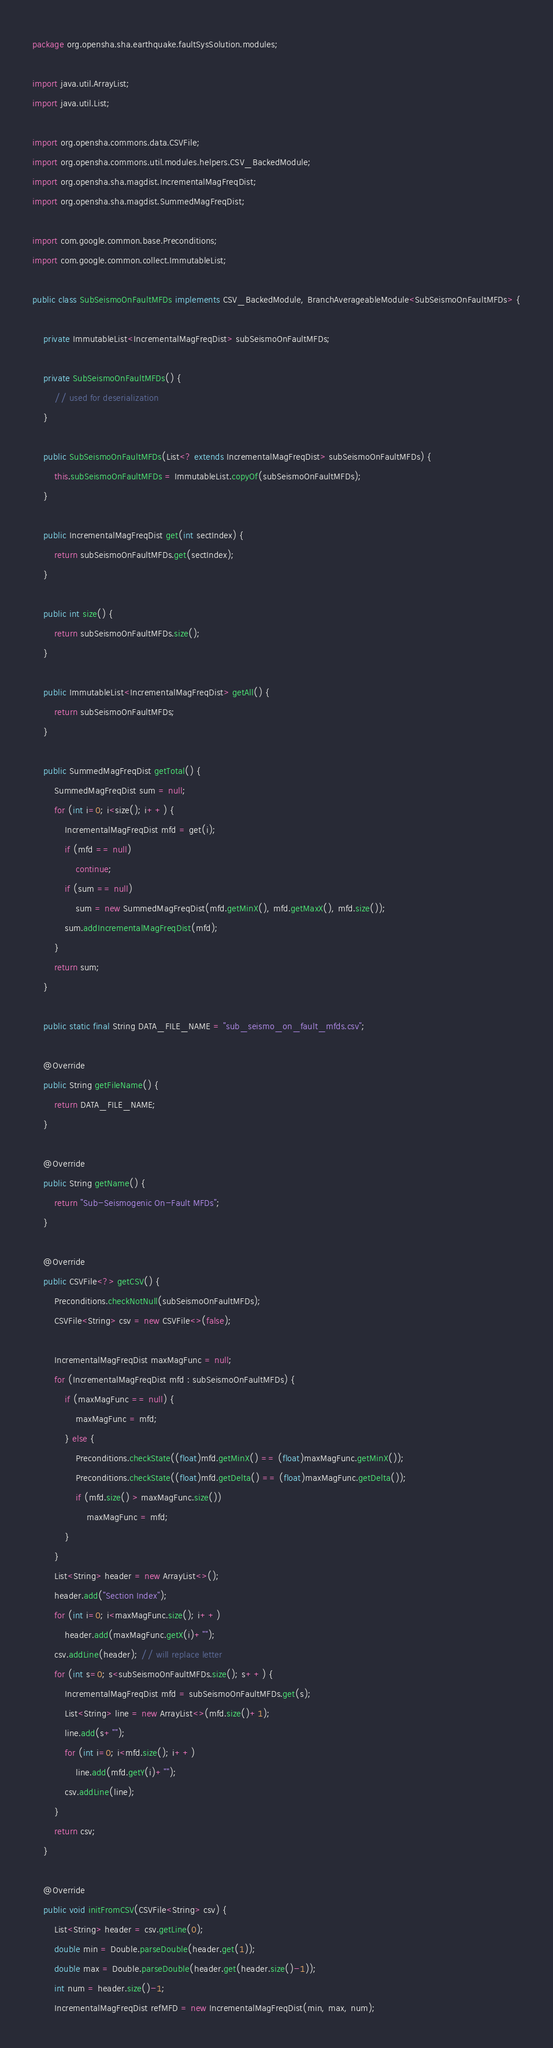Convert code to text. <code><loc_0><loc_0><loc_500><loc_500><_Java_>package org.opensha.sha.earthquake.faultSysSolution.modules;

import java.util.ArrayList;
import java.util.List;

import org.opensha.commons.data.CSVFile;
import org.opensha.commons.util.modules.helpers.CSV_BackedModule;
import org.opensha.sha.magdist.IncrementalMagFreqDist;
import org.opensha.sha.magdist.SummedMagFreqDist;

import com.google.common.base.Preconditions;
import com.google.common.collect.ImmutableList;

public class SubSeismoOnFaultMFDs implements CSV_BackedModule, BranchAverageableModule<SubSeismoOnFaultMFDs> {
	
	private ImmutableList<IncrementalMagFreqDist> subSeismoOnFaultMFDs;
	
	private SubSeismoOnFaultMFDs() {
		// used for deserialization
	}
	
	public SubSeismoOnFaultMFDs(List<? extends IncrementalMagFreqDist> subSeismoOnFaultMFDs) {
		this.subSeismoOnFaultMFDs = ImmutableList.copyOf(subSeismoOnFaultMFDs);
	}
	
	public IncrementalMagFreqDist get(int sectIndex) {
		return subSeismoOnFaultMFDs.get(sectIndex);
	}
	
	public int size() {
		return subSeismoOnFaultMFDs.size();
	}
	
	public ImmutableList<IncrementalMagFreqDist> getAll() {
		return subSeismoOnFaultMFDs;
	}
	
	public SummedMagFreqDist getTotal() {
		SummedMagFreqDist sum = null;
		for (int i=0; i<size(); i++) {
			IncrementalMagFreqDist mfd = get(i);
			if (mfd == null)
				continue;
			if (sum == null)
				sum = new SummedMagFreqDist(mfd.getMinX(), mfd.getMaxX(), mfd.size());
			sum.addIncrementalMagFreqDist(mfd);
		}
		return sum;
	}
	
	public static final String DATA_FILE_NAME = "sub_seismo_on_fault_mfds.csv";

	@Override
	public String getFileName() {
		return DATA_FILE_NAME;
	}

	@Override
	public String getName() {
		return "Sub-Seismogenic On-Fault MFDs";
	}

	@Override
	public CSVFile<?> getCSV() {
		Preconditions.checkNotNull(subSeismoOnFaultMFDs);
		CSVFile<String> csv = new CSVFile<>(false);
		
		IncrementalMagFreqDist maxMagFunc = null;
		for (IncrementalMagFreqDist mfd : subSeismoOnFaultMFDs) {
			if (maxMagFunc == null) {
				maxMagFunc = mfd;
			} else {
				Preconditions.checkState((float)mfd.getMinX() == (float)maxMagFunc.getMinX());
				Preconditions.checkState((float)mfd.getDelta() == (float)maxMagFunc.getDelta());
				if (mfd.size() > maxMagFunc.size())
					maxMagFunc = mfd;
			}
		}
		List<String> header = new ArrayList<>();
		header.add("Section Index");
		for (int i=0; i<maxMagFunc.size(); i++)
			header.add(maxMagFunc.getX(i)+"");
		csv.addLine(header); // will replace letter
		for (int s=0; s<subSeismoOnFaultMFDs.size(); s++) {
			IncrementalMagFreqDist mfd = subSeismoOnFaultMFDs.get(s);
			List<String> line = new ArrayList<>(mfd.size()+1);
			line.add(s+"");
			for (int i=0; i<mfd.size(); i++)
				line.add(mfd.getY(i)+"");
			csv.addLine(line);
		}
		return csv;
	}

	@Override
	public void initFromCSV(CSVFile<String> csv) {
		List<String> header = csv.getLine(0);
		double min = Double.parseDouble(header.get(1));
		double max = Double.parseDouble(header.get(header.size()-1));
		int num = header.size()-1;
		IncrementalMagFreqDist refMFD = new IncrementalMagFreqDist(min, max, num);</code> 